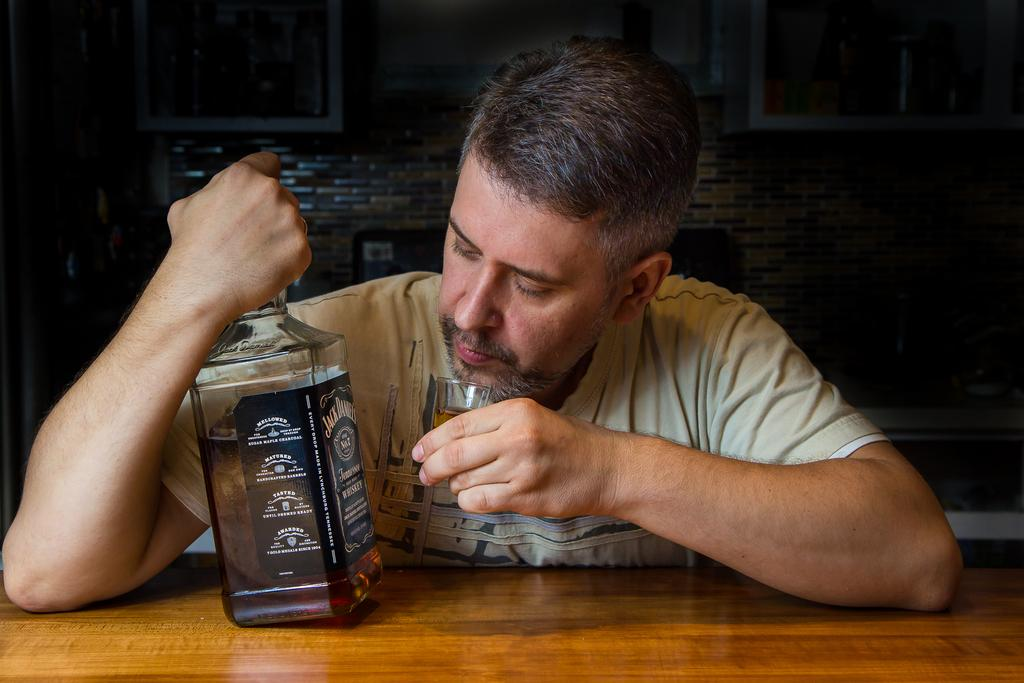Who is present in the image? There is a man in the image. What is the man holding in one hand? The man is holding a glass in one hand. What is the man holding in the other hand? The man is holding a bottle in the other hand. What can be seen on the table in the image? The table is not mentioned in the provided facts, so we cannot determine what is on it. What is visible in the background of the image? There is a wall and a window in the background of the image. What color are the man's eyes in the image? The provided facts do not mention the man's eyes, so we cannot determine their color. Is there a chain hanging from the ceiling in the image? There is no mention of a chain in the provided facts, so we cannot determine if one is present. 